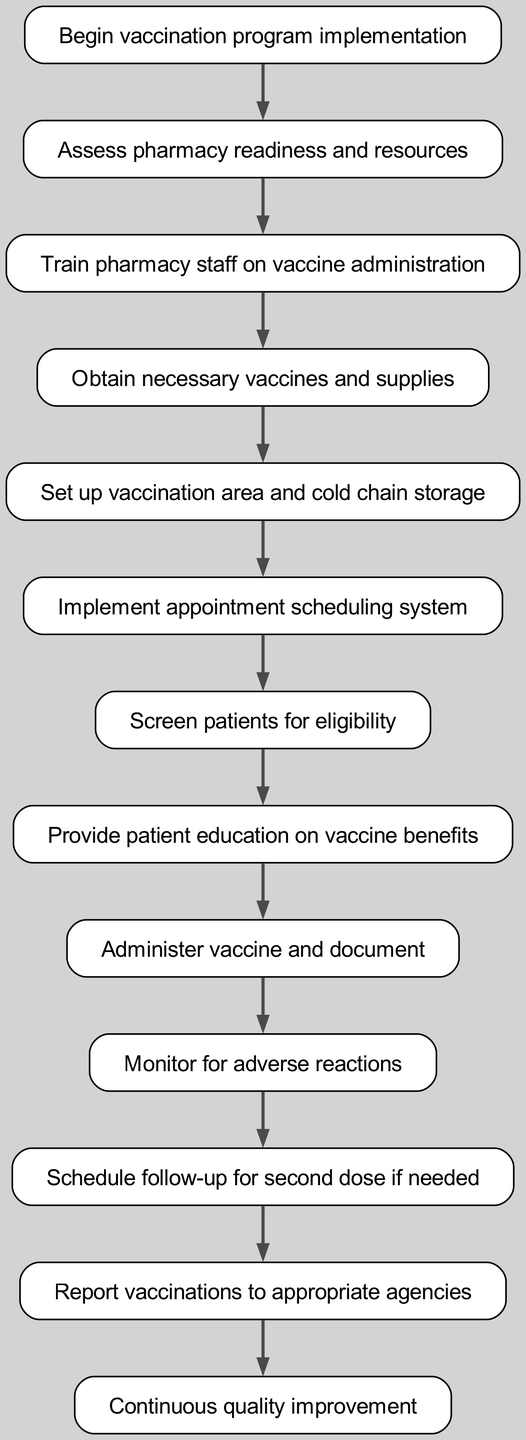What is the first step in the vaccination program implementation? The first step is represented by the node labeled "Begin vaccination program implementation." This is the starting point of the flowchart, indicating where the process initiates.
Answer: Begin vaccination program implementation How many steps are in the workflow? By counting the distinct nodes in the diagram, which are connected by directed edges, I find there are a total of 13 steps listed in the flowchart.
Answer: 13 What is the last action taken in the workflow? The last action is indicated by the node labeled "Continuous quality improvement." This step signifies the conclusion of the vaccination program implementation workflow and emphasizes ongoing enhancement efforts.
Answer: Continuous quality improvement What step directly follows "Screen patients for eligibility"? The immediate next step following "Screen patients for eligibility" is "Provide patient education on vaccine benefits." This shows the logical progression of activities in the workflow.
Answer: Provide patient education on vaccine benefits Which nodes are involved in the administration of the vaccine? The nodes involved in the administration of the vaccine include "Administer vaccine and document," "Monitor for adverse reactions," and "Schedule follow-up for second dose if needed." All of these steps are crucial for the vaccination process and the subsequent care of patients.
Answer: Administer vaccine and document, Monitor for adverse reactions, Schedule follow-up for second dose if needed What step comes after obtaining necessary vaccines and supplies? "Set up vaccination area and cold chain storage" directly follows the step where necessary vaccines and supplies are obtained. This indicates that preparation of the physical environment for vaccination occurs after securing the necessary resources.
Answer: Set up vaccination area and cold chain storage How many connections are there between steps in the workflow? By counting the arrows (edges) connecting the nodes, I determine that there are a total of 12 connections or links between the steps in the flowchart.
Answer: 12 What is the relationship between "Train pharmacy staff on vaccine administration" and "Obtain necessary vaccines and supplies"? The relationship is sequential, as "Train pharmacy staff on vaccine administration" directly leads to "Obtain necessary vaccines and supplies." This means that staff training must occur before necessary resources can be acquired.
Answer: Sequential connection What is the purpose of the "Report vaccinations to appropriate agencies" step? This step serves the purpose of ensuring compliance and communication with public health agencies, which helps in tracking vaccination rates and ensuring accountability within the vaccination program.
Answer: Compliance and communication with public health agencies 